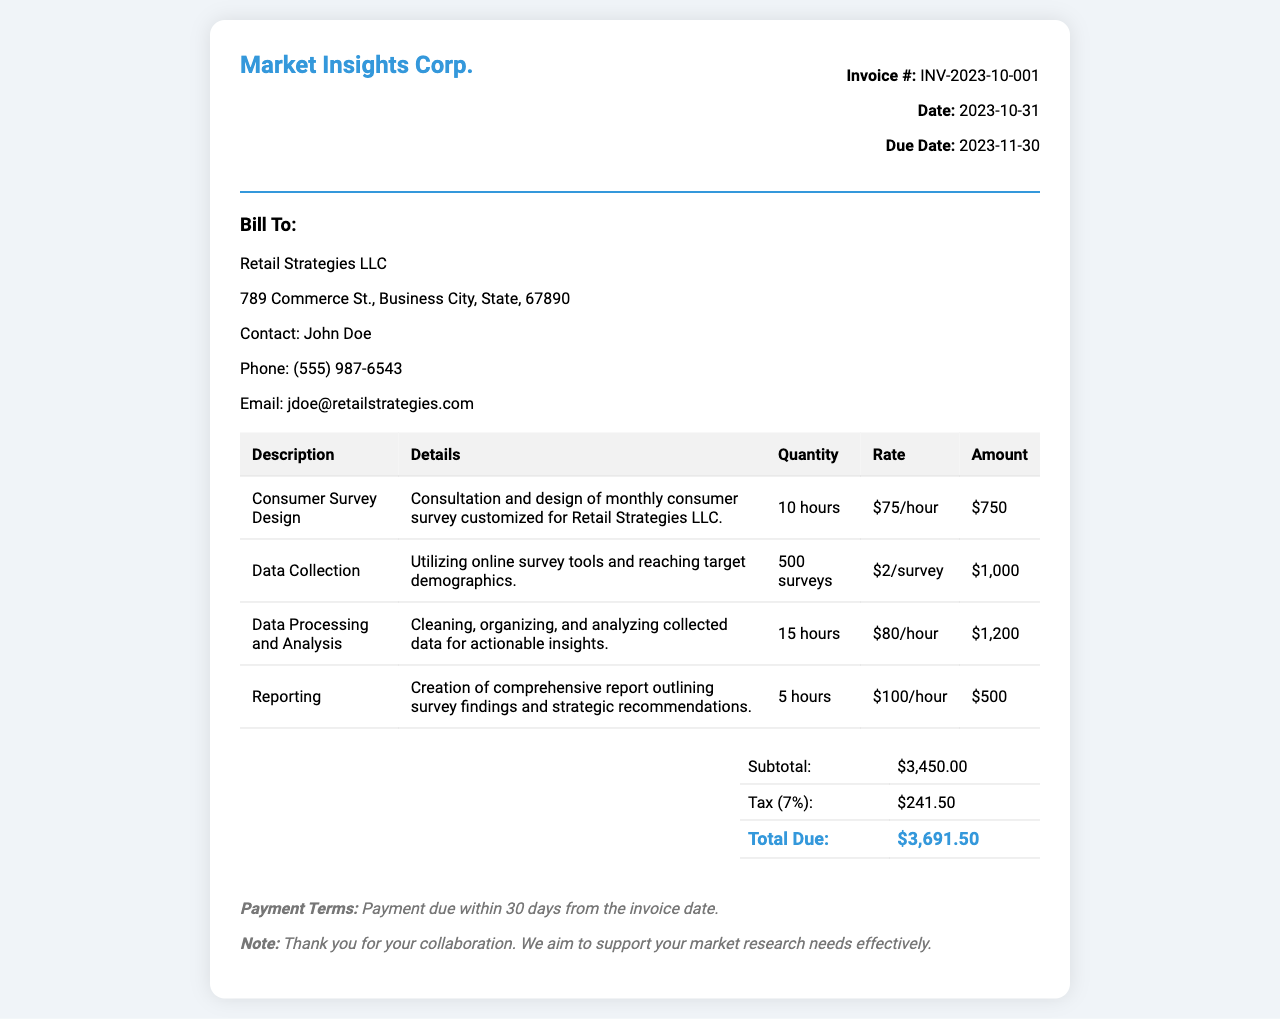What is the invoice number? The invoice number is indicated at the top of the document, which helps to identify the specific invoice.
Answer: INV-2023-10-001 What is the total amount due? The total amount due is calculated at the bottom of the invoice after taxes are included.
Answer: $3,691.50 Who is the contact person for the client? The contact person's name is provided in the client info section for communication purposes.
Answer: John Doe How many surveys were collected? The quantity of surveys collected is specified in the section detailing data collection services.
Answer: 500 surveys What service had the highest cost? To find this, we compare the costs for each service detailed in the invoice.
Answer: Data Processing and Analysis What is the tax rate applied to the subtotal? The tax rate is mentioned in the summary section to determine the total due.
Answer: 7% How many hours were spent on Reporting? The hours dedicated to reporting are mentioned in the table of services provided.
Answer: 5 hours What is the due date for payment? The due date is listed above the client information and indicates when payment is expected.
Answer: 2023-11-30 What kind of report was created? The report type is described in the reporting section of the invoice, outlining its purpose.
Answer: Comprehensive report 